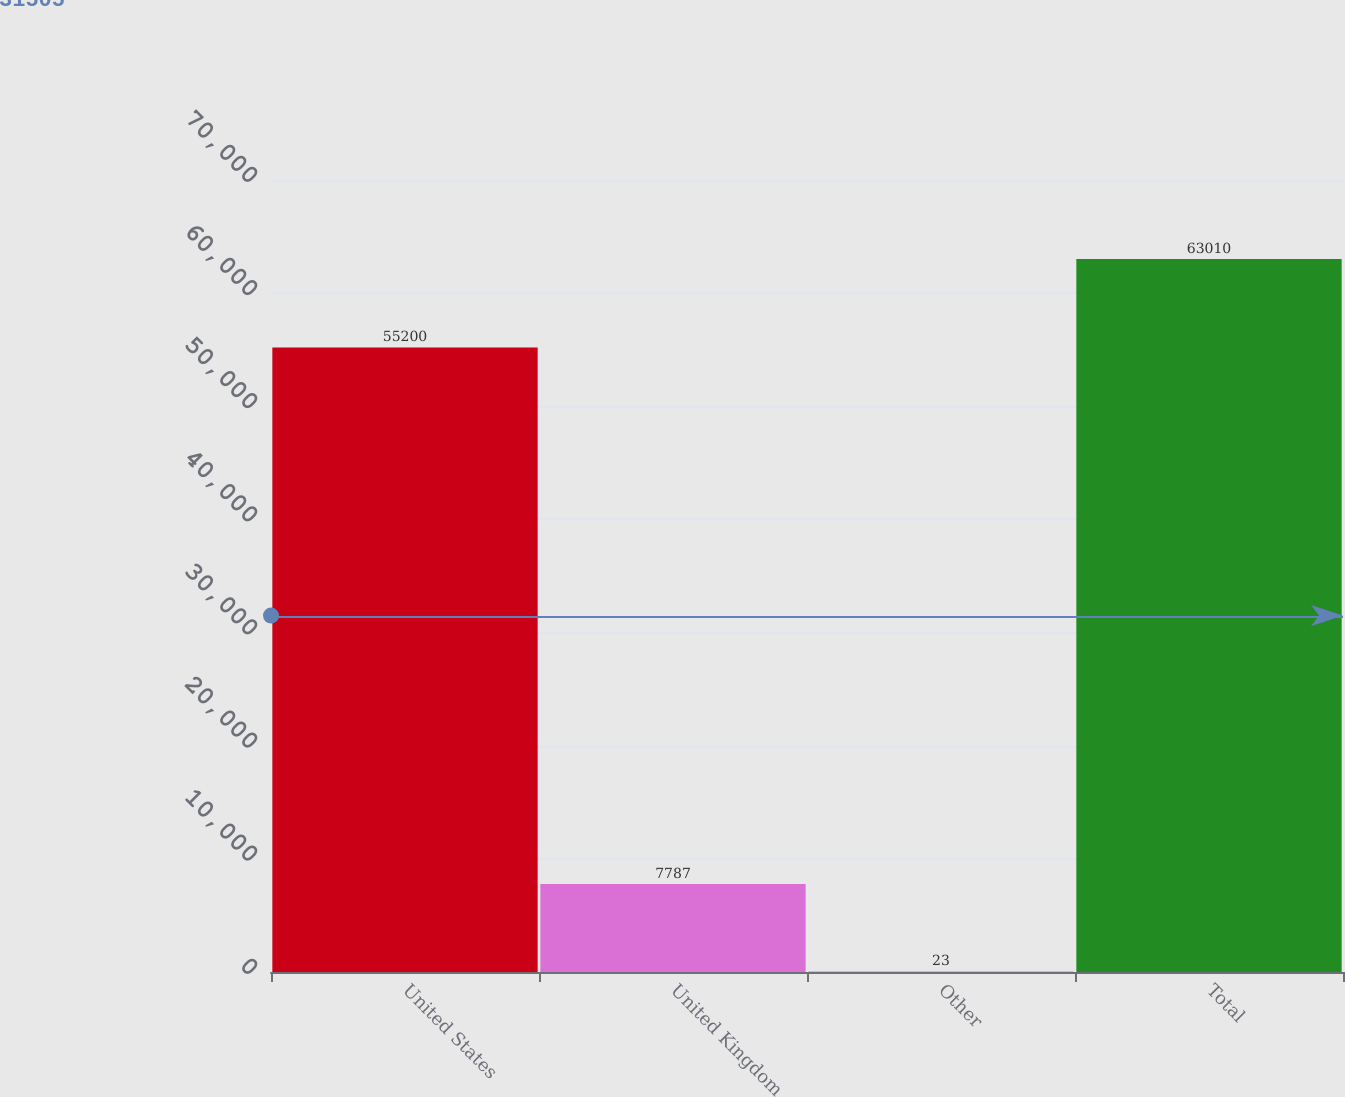Convert chart to OTSL. <chart><loc_0><loc_0><loc_500><loc_500><bar_chart><fcel>United States<fcel>United Kingdom<fcel>Other<fcel>Total<nl><fcel>55200<fcel>7787<fcel>23<fcel>63010<nl></chart> 